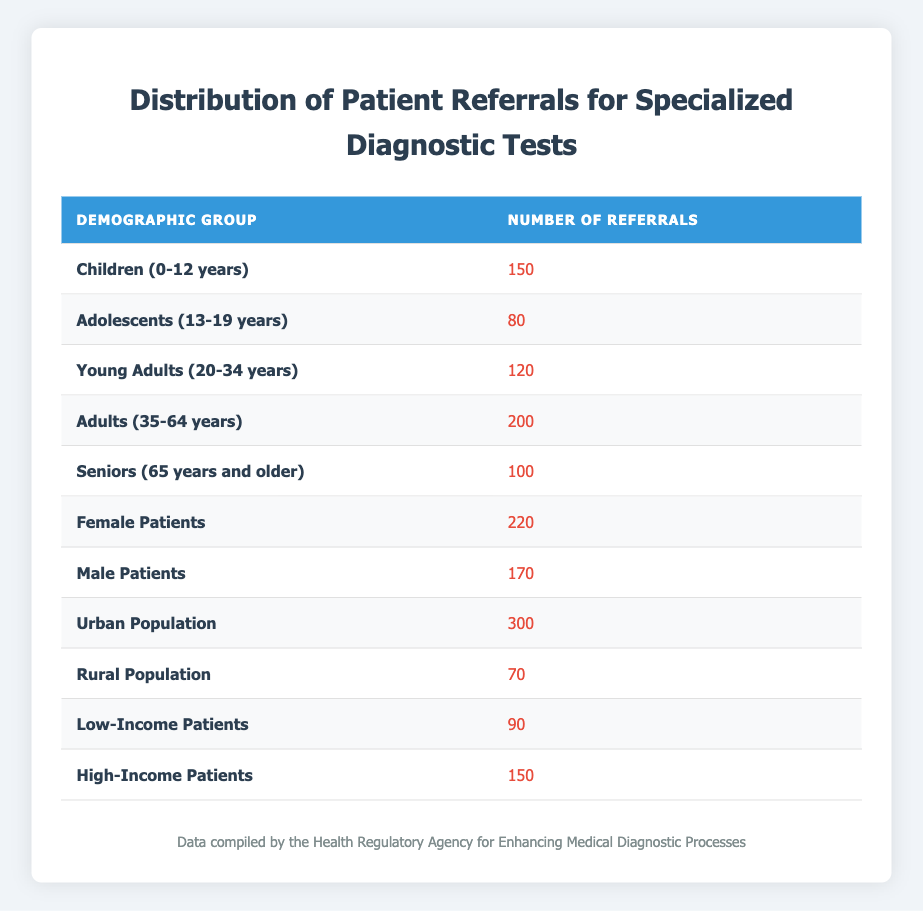What is the total number of referrals for Adults (35-64 years)? Looking at the table, the number of referrals for Adults (35-64 years) is listed as 200, so the total is simply that value.
Answer: 200 Which demographic group has the highest number of referrals? By comparing all the referral numbers in the table, Urban Population has the highest number at 300 referrals.
Answer: Urban Population What is the sum of referrals for Female and Male Patients? The number of referrals for Female Patients is 220 and for Male Patients is 170. Adding these two values gives 220 + 170 = 390.
Answer: 390 Are there more referrals for Young Adults (20-34 years) than for Adolescents (13-19 years)? Young Adults have 120 referrals while Adolescents have 80. Since 120 is greater than 80, the statement is true.
Answer: Yes What is the average number of referrals for urban and rural populations combined? Urban Population has 300 referrals and Rural Population has 70 referrals, which sums to 300 + 70 = 370. To find the average, divide by the number of groups (2): 370 / 2 = 185.
Answer: 185 Is the number of referrals for Children (0-12 years) more than the number for Seniors (65 years and older)? Children have 150 referrals and Seniors have 100. Since 150 is greater than 100, the answer is true.
Answer: Yes How many more referrals do Female Patients have compared to Low-Income Patients? Female Patients have 220 referrals while Low-Income Patients have 90. Subtracting these gives 220 - 90 = 130, meaning Female Patients have 130 more referrals.
Answer: 130 Which demographic group received fewer than 100 referrals? In the table, the only group that received fewer than 100 referrals is the Rural Population, with 70 referrals.
Answer: Rural Population What is the total number of referrals across all demographics? To find the total, sum all the referral numbers: 150 + 80 + 120 + 200 + 100 + 220 + 170 + 300 + 70 + 90 + 150 = 1,650.
Answer: 1650 